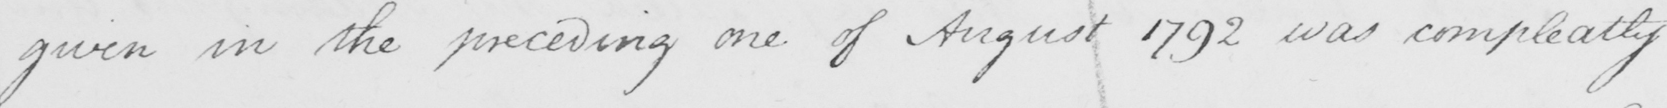Please provide the text content of this handwritten line. given in the preceding one of August 1792 was compleatly 